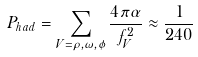Convert formula to latex. <formula><loc_0><loc_0><loc_500><loc_500>P _ { h a d } = \sum _ { V = \rho , \omega , \phi } { \frac { 4 \pi \alpha } { f _ { V } ^ { 2 } } } \approx { \frac { 1 } { 2 4 0 } }</formula> 